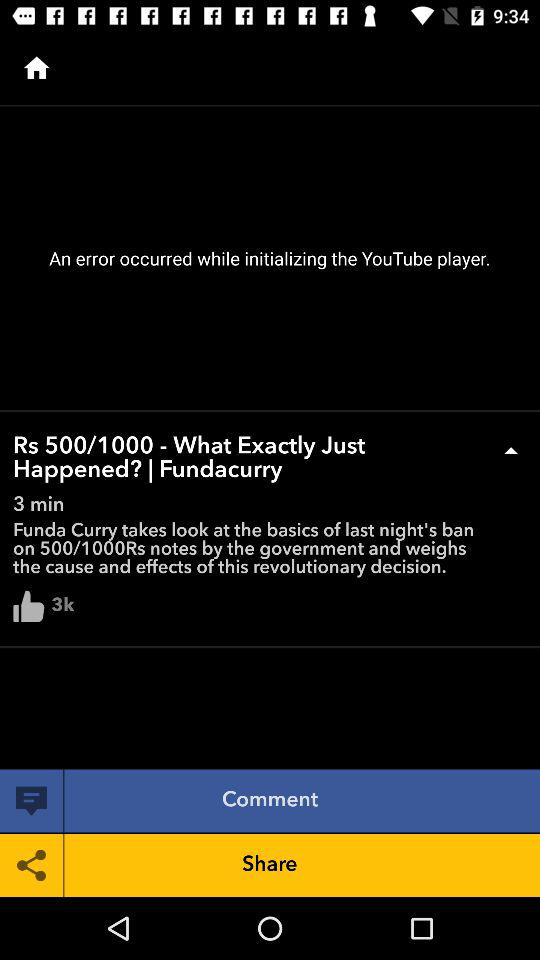What is the total length of the video? The total length of the video is 3 minutes. 